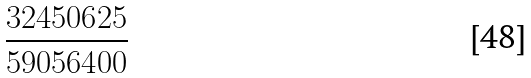Convert formula to latex. <formula><loc_0><loc_0><loc_500><loc_500>\frac { 3 2 4 5 0 6 2 5 } { 5 9 0 5 6 4 0 0 }</formula> 